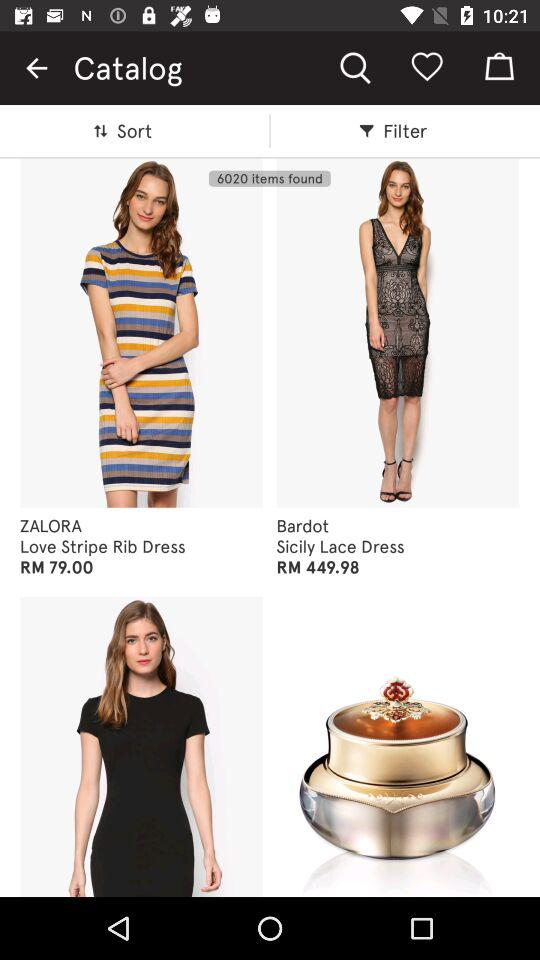What is the price of the "Sicily Lace Dress"? The price of the "Sicily Lace Dress" is RM449.98. 